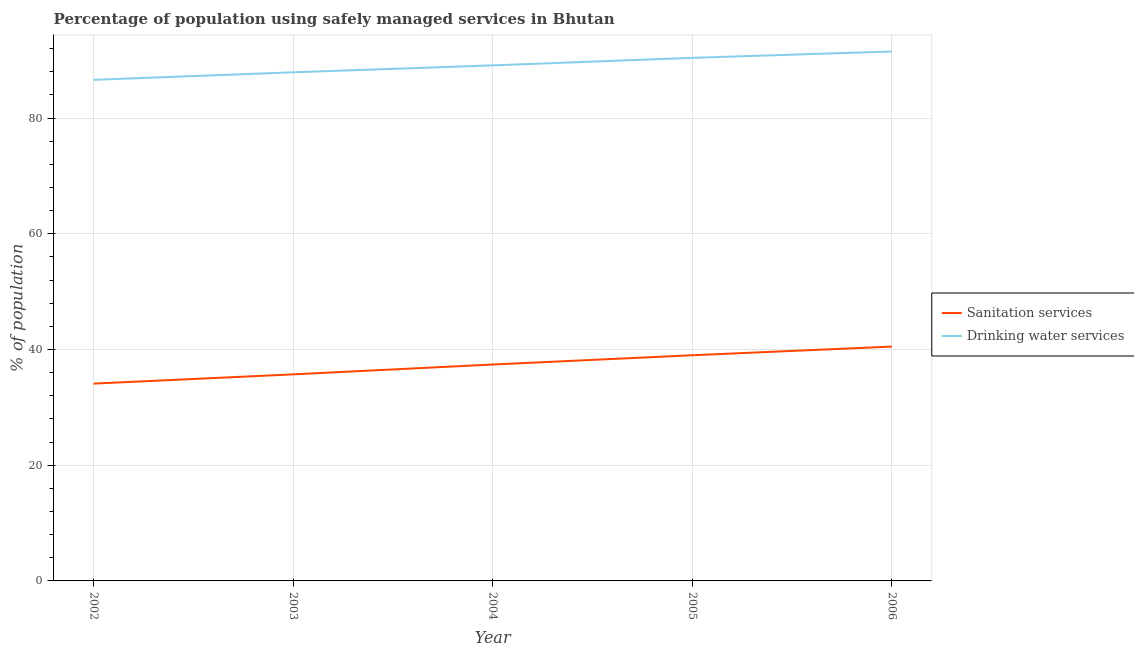How many different coloured lines are there?
Offer a terse response. 2. Is the number of lines equal to the number of legend labels?
Your answer should be compact. Yes. What is the percentage of population who used drinking water services in 2004?
Provide a succinct answer. 89.1. Across all years, what is the maximum percentage of population who used drinking water services?
Keep it short and to the point. 91.5. Across all years, what is the minimum percentage of population who used sanitation services?
Give a very brief answer. 34.1. In which year was the percentage of population who used sanitation services maximum?
Give a very brief answer. 2006. What is the total percentage of population who used drinking water services in the graph?
Your answer should be very brief. 445.5. What is the difference between the percentage of population who used drinking water services in 2002 and that in 2006?
Make the answer very short. -4.9. What is the difference between the percentage of population who used drinking water services in 2003 and the percentage of population who used sanitation services in 2002?
Ensure brevity in your answer.  53.8. What is the average percentage of population who used sanitation services per year?
Provide a short and direct response. 37.34. In the year 2003, what is the difference between the percentage of population who used drinking water services and percentage of population who used sanitation services?
Your response must be concise. 52.2. In how many years, is the percentage of population who used drinking water services greater than 16 %?
Offer a very short reply. 5. What is the ratio of the percentage of population who used sanitation services in 2004 to that in 2005?
Offer a very short reply. 0.96. Is the percentage of population who used sanitation services in 2005 less than that in 2006?
Offer a very short reply. Yes. What is the difference between the highest and the second highest percentage of population who used sanitation services?
Provide a succinct answer. 1.5. What is the difference between the highest and the lowest percentage of population who used drinking water services?
Make the answer very short. 4.9. Is the sum of the percentage of population who used drinking water services in 2002 and 2005 greater than the maximum percentage of population who used sanitation services across all years?
Ensure brevity in your answer.  Yes. Does the percentage of population who used drinking water services monotonically increase over the years?
Your answer should be compact. Yes. Is the percentage of population who used drinking water services strictly greater than the percentage of population who used sanitation services over the years?
Your answer should be very brief. Yes. Is the percentage of population who used sanitation services strictly less than the percentage of population who used drinking water services over the years?
Make the answer very short. Yes. How many lines are there?
Your response must be concise. 2. How many years are there in the graph?
Make the answer very short. 5. What is the difference between two consecutive major ticks on the Y-axis?
Make the answer very short. 20. Does the graph contain grids?
Offer a terse response. Yes. Where does the legend appear in the graph?
Ensure brevity in your answer.  Center right. How are the legend labels stacked?
Keep it short and to the point. Vertical. What is the title of the graph?
Your answer should be very brief. Percentage of population using safely managed services in Bhutan. Does "constant 2005 US$" appear as one of the legend labels in the graph?
Your response must be concise. No. What is the label or title of the Y-axis?
Your answer should be very brief. % of population. What is the % of population in Sanitation services in 2002?
Make the answer very short. 34.1. What is the % of population of Drinking water services in 2002?
Ensure brevity in your answer.  86.6. What is the % of population in Sanitation services in 2003?
Offer a terse response. 35.7. What is the % of population of Drinking water services in 2003?
Keep it short and to the point. 87.9. What is the % of population in Sanitation services in 2004?
Offer a terse response. 37.4. What is the % of population of Drinking water services in 2004?
Make the answer very short. 89.1. What is the % of population in Drinking water services in 2005?
Provide a succinct answer. 90.4. What is the % of population of Sanitation services in 2006?
Your answer should be compact. 40.5. What is the % of population of Drinking water services in 2006?
Your answer should be compact. 91.5. Across all years, what is the maximum % of population in Sanitation services?
Offer a very short reply. 40.5. Across all years, what is the maximum % of population of Drinking water services?
Your answer should be compact. 91.5. Across all years, what is the minimum % of population in Sanitation services?
Your answer should be very brief. 34.1. Across all years, what is the minimum % of population in Drinking water services?
Ensure brevity in your answer.  86.6. What is the total % of population of Sanitation services in the graph?
Your answer should be very brief. 186.7. What is the total % of population in Drinking water services in the graph?
Keep it short and to the point. 445.5. What is the difference between the % of population of Sanitation services in 2002 and that in 2003?
Make the answer very short. -1.6. What is the difference between the % of population of Sanitation services in 2002 and that in 2006?
Provide a short and direct response. -6.4. What is the difference between the % of population of Sanitation services in 2003 and that in 2005?
Offer a very short reply. -3.3. What is the difference between the % of population in Drinking water services in 2003 and that in 2005?
Your answer should be very brief. -2.5. What is the difference between the % of population of Sanitation services in 2003 and that in 2006?
Your response must be concise. -4.8. What is the difference between the % of population in Drinking water services in 2003 and that in 2006?
Offer a very short reply. -3.6. What is the difference between the % of population in Sanitation services in 2004 and that in 2005?
Your answer should be very brief. -1.6. What is the difference between the % of population in Drinking water services in 2004 and that in 2005?
Your answer should be compact. -1.3. What is the difference between the % of population of Drinking water services in 2004 and that in 2006?
Make the answer very short. -2.4. What is the difference between the % of population of Drinking water services in 2005 and that in 2006?
Ensure brevity in your answer.  -1.1. What is the difference between the % of population in Sanitation services in 2002 and the % of population in Drinking water services in 2003?
Offer a terse response. -53.8. What is the difference between the % of population in Sanitation services in 2002 and the % of population in Drinking water services in 2004?
Ensure brevity in your answer.  -55. What is the difference between the % of population in Sanitation services in 2002 and the % of population in Drinking water services in 2005?
Offer a very short reply. -56.3. What is the difference between the % of population of Sanitation services in 2002 and the % of population of Drinking water services in 2006?
Offer a terse response. -57.4. What is the difference between the % of population of Sanitation services in 2003 and the % of population of Drinking water services in 2004?
Keep it short and to the point. -53.4. What is the difference between the % of population of Sanitation services in 2003 and the % of population of Drinking water services in 2005?
Provide a short and direct response. -54.7. What is the difference between the % of population of Sanitation services in 2003 and the % of population of Drinking water services in 2006?
Your response must be concise. -55.8. What is the difference between the % of population in Sanitation services in 2004 and the % of population in Drinking water services in 2005?
Give a very brief answer. -53. What is the difference between the % of population of Sanitation services in 2004 and the % of population of Drinking water services in 2006?
Ensure brevity in your answer.  -54.1. What is the difference between the % of population of Sanitation services in 2005 and the % of population of Drinking water services in 2006?
Offer a very short reply. -52.5. What is the average % of population of Sanitation services per year?
Give a very brief answer. 37.34. What is the average % of population in Drinking water services per year?
Your response must be concise. 89.1. In the year 2002, what is the difference between the % of population in Sanitation services and % of population in Drinking water services?
Ensure brevity in your answer.  -52.5. In the year 2003, what is the difference between the % of population in Sanitation services and % of population in Drinking water services?
Provide a short and direct response. -52.2. In the year 2004, what is the difference between the % of population of Sanitation services and % of population of Drinking water services?
Offer a very short reply. -51.7. In the year 2005, what is the difference between the % of population in Sanitation services and % of population in Drinking water services?
Your response must be concise. -51.4. In the year 2006, what is the difference between the % of population in Sanitation services and % of population in Drinking water services?
Keep it short and to the point. -51. What is the ratio of the % of population of Sanitation services in 2002 to that in 2003?
Provide a succinct answer. 0.96. What is the ratio of the % of population in Drinking water services in 2002 to that in 2003?
Keep it short and to the point. 0.99. What is the ratio of the % of population of Sanitation services in 2002 to that in 2004?
Keep it short and to the point. 0.91. What is the ratio of the % of population of Drinking water services in 2002 to that in 2004?
Keep it short and to the point. 0.97. What is the ratio of the % of population in Sanitation services in 2002 to that in 2005?
Your answer should be very brief. 0.87. What is the ratio of the % of population of Drinking water services in 2002 to that in 2005?
Ensure brevity in your answer.  0.96. What is the ratio of the % of population in Sanitation services in 2002 to that in 2006?
Your response must be concise. 0.84. What is the ratio of the % of population in Drinking water services in 2002 to that in 2006?
Give a very brief answer. 0.95. What is the ratio of the % of population in Sanitation services in 2003 to that in 2004?
Offer a very short reply. 0.95. What is the ratio of the % of population of Drinking water services in 2003 to that in 2004?
Provide a short and direct response. 0.99. What is the ratio of the % of population in Sanitation services in 2003 to that in 2005?
Make the answer very short. 0.92. What is the ratio of the % of population in Drinking water services in 2003 to that in 2005?
Give a very brief answer. 0.97. What is the ratio of the % of population of Sanitation services in 2003 to that in 2006?
Provide a short and direct response. 0.88. What is the ratio of the % of population of Drinking water services in 2003 to that in 2006?
Your answer should be very brief. 0.96. What is the ratio of the % of population of Drinking water services in 2004 to that in 2005?
Offer a very short reply. 0.99. What is the ratio of the % of population in Sanitation services in 2004 to that in 2006?
Keep it short and to the point. 0.92. What is the ratio of the % of population of Drinking water services in 2004 to that in 2006?
Provide a short and direct response. 0.97. What is the ratio of the % of population of Sanitation services in 2005 to that in 2006?
Keep it short and to the point. 0.96. What is the difference between the highest and the second highest % of population in Sanitation services?
Provide a short and direct response. 1.5. What is the difference between the highest and the second highest % of population in Drinking water services?
Your response must be concise. 1.1. What is the difference between the highest and the lowest % of population of Drinking water services?
Keep it short and to the point. 4.9. 